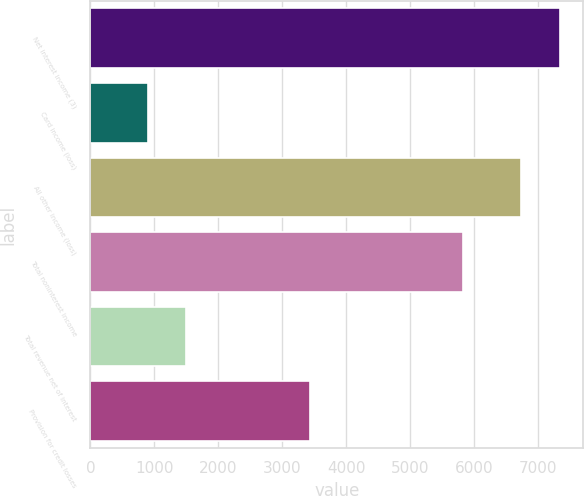Convert chart. <chart><loc_0><loc_0><loc_500><loc_500><bar_chart><fcel>Net interest income (3)<fcel>Card income (loss)<fcel>All other income (loss)<fcel>Total noninterest income<fcel>Total revenue net of interest<fcel>Provision for credit losses<nl><fcel>7337.7<fcel>895<fcel>6735<fcel>5830<fcel>1497.7<fcel>3431<nl></chart> 